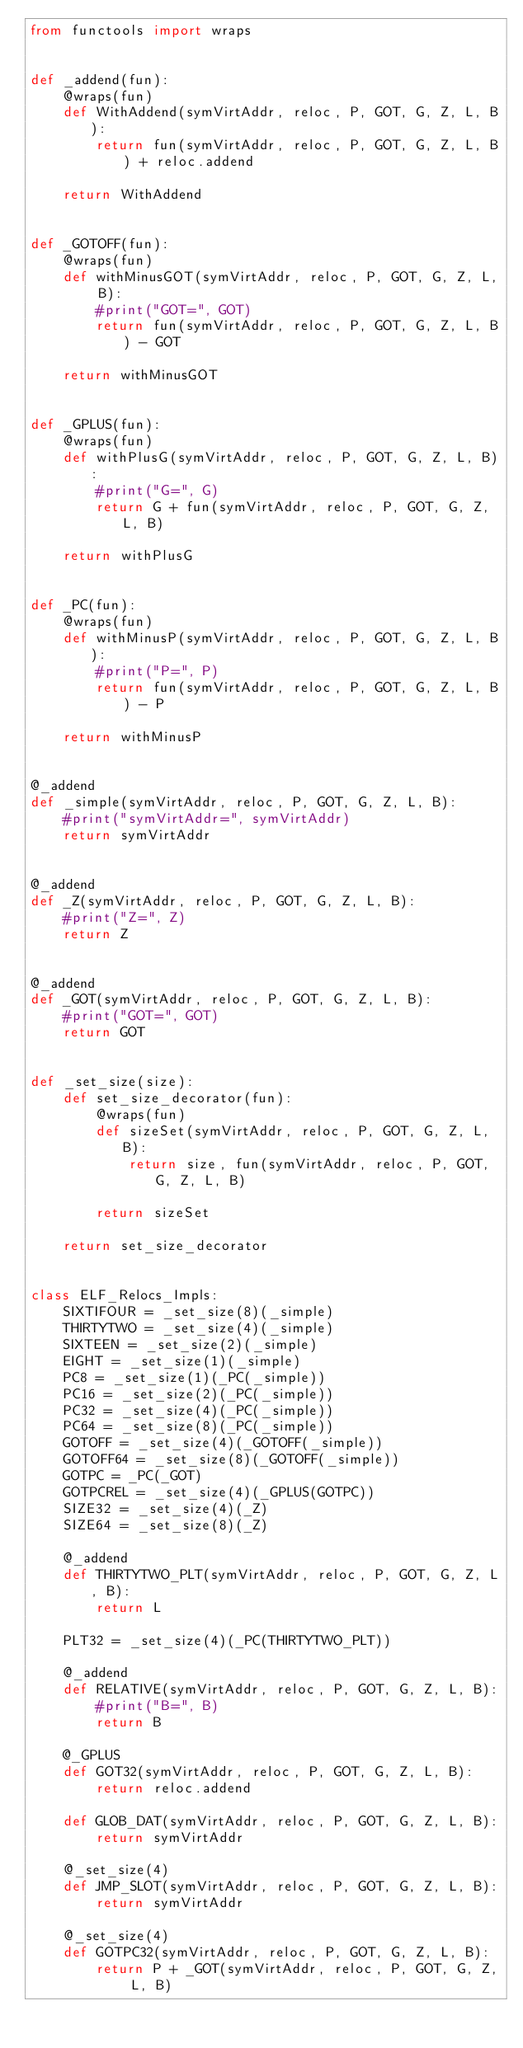Convert code to text. <code><loc_0><loc_0><loc_500><loc_500><_Python_>from functools import wraps


def _addend(fun):
	@wraps(fun)
	def WithAddend(symVirtAddr, reloc, P, GOT, G, Z, L, B):
		return fun(symVirtAddr, reloc, P, GOT, G, Z, L, B) + reloc.addend

	return WithAddend


def _GOTOFF(fun):
	@wraps(fun)
	def withMinusGOT(symVirtAddr, reloc, P, GOT, G, Z, L, B):
		#print("GOT=", GOT)
		return fun(symVirtAddr, reloc, P, GOT, G, Z, L, B) - GOT

	return withMinusGOT


def _GPLUS(fun):
	@wraps(fun)
	def withPlusG(symVirtAddr, reloc, P, GOT, G, Z, L, B):
		#print("G=", G)
		return G + fun(symVirtAddr, reloc, P, GOT, G, Z, L, B)

	return withPlusG


def _PC(fun):
	@wraps(fun)
	def withMinusP(symVirtAddr, reloc, P, GOT, G, Z, L, B):
		#print("P=", P)
		return fun(symVirtAddr, reloc, P, GOT, G, Z, L, B) - P

	return withMinusP


@_addend
def _simple(symVirtAddr, reloc, P, GOT, G, Z, L, B):
	#print("symVirtAddr=", symVirtAddr)
	return symVirtAddr


@_addend
def _Z(symVirtAddr, reloc, P, GOT, G, Z, L, B):
	#print("Z=", Z)
	return Z


@_addend
def _GOT(symVirtAddr, reloc, P, GOT, G, Z, L, B):
	#print("GOT=", GOT)
	return GOT


def _set_size(size):
	def set_size_decorator(fun):
		@wraps(fun)
		def sizeSet(symVirtAddr, reloc, P, GOT, G, Z, L, B):
			return size, fun(symVirtAddr, reloc, P, GOT, G, Z, L, B)

		return sizeSet

	return set_size_decorator


class ELF_Relocs_Impls:
	SIXTIFOUR = _set_size(8)(_simple)
	THIRTYTWO = _set_size(4)(_simple)
	SIXTEEN = _set_size(2)(_simple)
	EIGHT = _set_size(1)(_simple)
	PC8 = _set_size(1)(_PC(_simple))
	PC16 = _set_size(2)(_PC(_simple))
	PC32 = _set_size(4)(_PC(_simple))
	PC64 = _set_size(8)(_PC(_simple))
	GOTOFF = _set_size(4)(_GOTOFF(_simple))
	GOTOFF64 = _set_size(8)(_GOTOFF(_simple))
	GOTPC = _PC(_GOT)
	GOTPCREL = _set_size(4)(_GPLUS(GOTPC))
	SIZE32 = _set_size(4)(_Z)
	SIZE64 = _set_size(8)(_Z)

	@_addend
	def THIRTYTWO_PLT(symVirtAddr, reloc, P, GOT, G, Z, L, B):
		return L

	PLT32 = _set_size(4)(_PC(THIRTYTWO_PLT))

	@_addend
	def RELATIVE(symVirtAddr, reloc, P, GOT, G, Z, L, B):
		#print("B=", B)
		return B

	@_GPLUS
	def GOT32(symVirtAddr, reloc, P, GOT, G, Z, L, B):
		return reloc.addend

	def GLOB_DAT(symVirtAddr, reloc, P, GOT, G, Z, L, B):
		return symVirtAddr

	@_set_size(4)
	def JMP_SLOT(symVirtAddr, reloc, P, GOT, G, Z, L, B):
		return symVirtAddr

	@_set_size(4)
	def GOTPC32(symVirtAddr, reloc, P, GOT, G, Z, L, B):
		return P + _GOT(symVirtAddr, reloc, P, GOT, G, Z, L, B)
</code> 